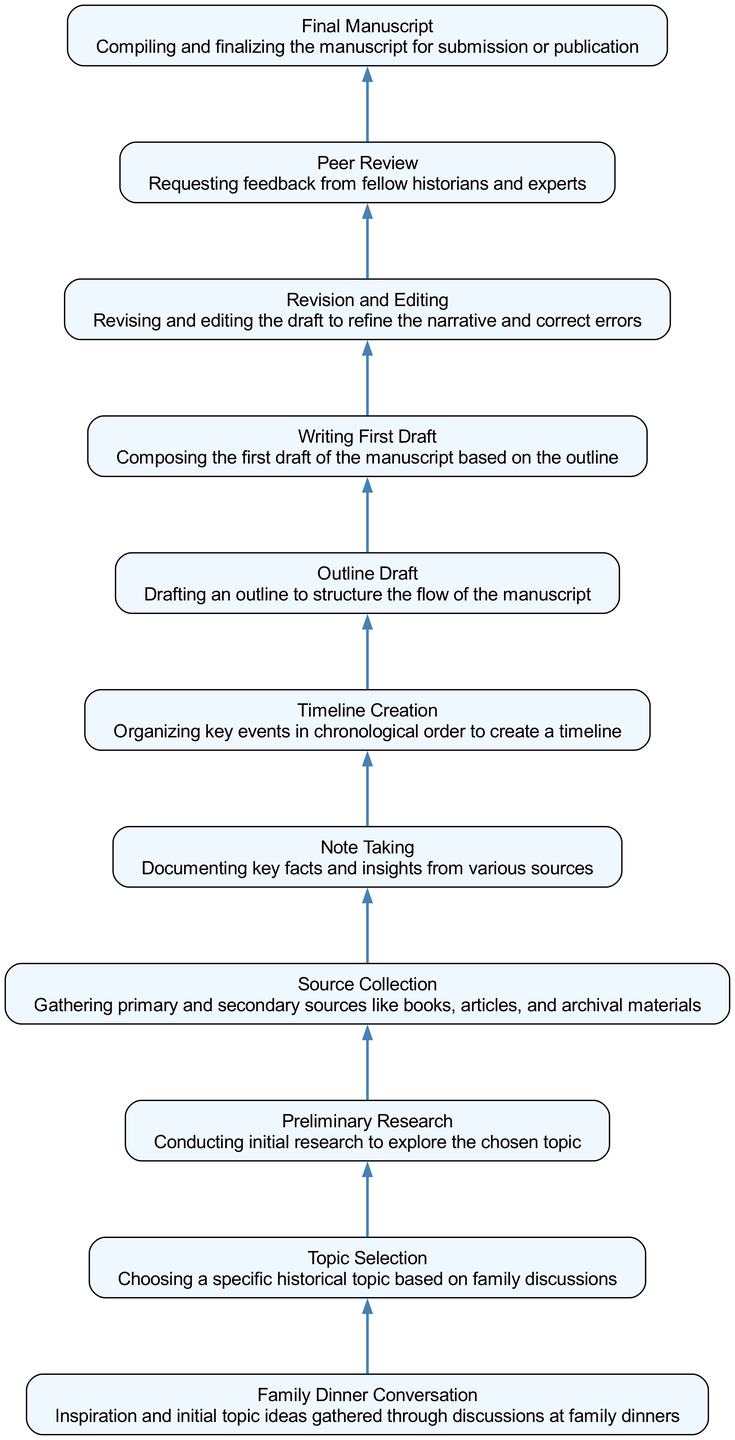What is the starting point of the flow chart? The starting point of the flow chart is "Family Dinner Conversation," which represents the initial inspiration gathered from discussions.
Answer: Family Dinner Conversation How many nodes are in the flow chart? By counting the elements listed in the data, we see there are ten nodes in the flow chart, each representing a stage in the development of historical research.
Answer: 10 What process follows "Source Collection"? The process that follows "Source Collection" is "Note Taking," where key facts and insights from the gathered sources are documented.
Answer: Note Taking Which step comes before "Writing First Draft"? "Outline Draft" comes before "Writing First Draft," as it involves structuring the manuscript before actual writing begins.
Answer: Outline Draft How many arrows connect the nodes? There are nine arrows connecting the nodes, indicating the sequential flow from one process to the next in the research development.
Answer: 9 What is the final stage in the flow chart? The final stage in the flow chart is "Final Manuscript," which indicates the completion and readiness for submission or publication.
Answer: Final Manuscript What is the relationship between "Preliminary Research" and "Topic Selection"? "Preliminary Research" follows "Topic Selection," indicating that once a topic is selected, initial research is conducted to explore it.
Answer: Sequential What are the last two processes in the flow chart? The last two processes in the flow chart are "Peer Review" and "Final Manuscript," showing the transition from seeking feedback to finalizing the document.
Answer: Peer Review, Final Manuscript What type of flow does the diagram illustrate? The diagram illustrates a bottom-to-top flow, indicating the progression of stages in the historical research process from conversations to manuscript.
Answer: Bottom-to-top 